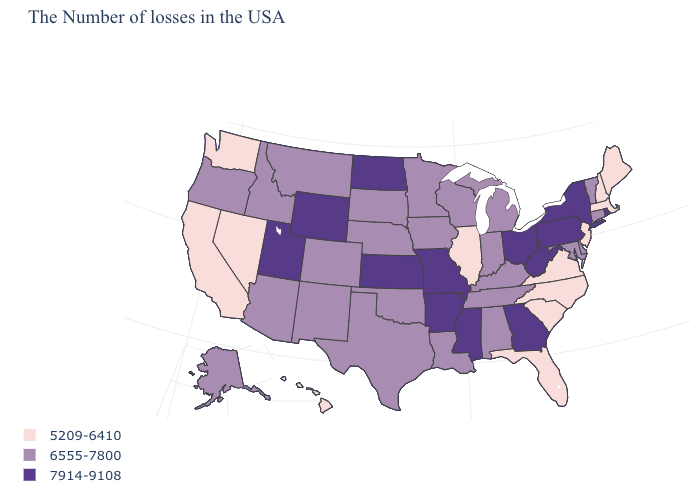Does West Virginia have a lower value than Maryland?
Quick response, please. No. Name the states that have a value in the range 6555-7800?
Give a very brief answer. Vermont, Connecticut, Delaware, Maryland, Michigan, Kentucky, Indiana, Alabama, Tennessee, Wisconsin, Louisiana, Minnesota, Iowa, Nebraska, Oklahoma, Texas, South Dakota, Colorado, New Mexico, Montana, Arizona, Idaho, Oregon, Alaska. What is the value of California?
Be succinct. 5209-6410. Among the states that border New Hampshire , does Maine have the lowest value?
Answer briefly. Yes. Does the map have missing data?
Quick response, please. No. How many symbols are there in the legend?
Keep it brief. 3. Among the states that border Kentucky , which have the highest value?
Be succinct. West Virginia, Ohio, Missouri. Does Connecticut have the same value as Missouri?
Concise answer only. No. Does New Mexico have the same value as South Carolina?
Be succinct. No. What is the value of Missouri?
Quick response, please. 7914-9108. What is the value of Mississippi?
Keep it brief. 7914-9108. Does Colorado have a lower value than Mississippi?
Answer briefly. Yes. Name the states that have a value in the range 5209-6410?
Keep it brief. Maine, Massachusetts, New Hampshire, New Jersey, Virginia, North Carolina, South Carolina, Florida, Illinois, Nevada, California, Washington, Hawaii. Among the states that border Virginia , does West Virginia have the highest value?
Write a very short answer. Yes. Name the states that have a value in the range 5209-6410?
Short answer required. Maine, Massachusetts, New Hampshire, New Jersey, Virginia, North Carolina, South Carolina, Florida, Illinois, Nevada, California, Washington, Hawaii. 